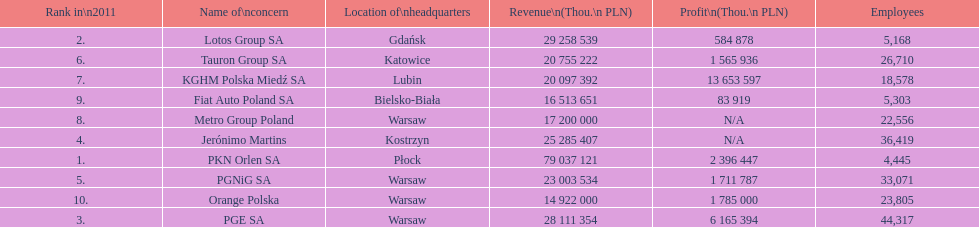How many companies had over $1,000,000 profit? 6. 